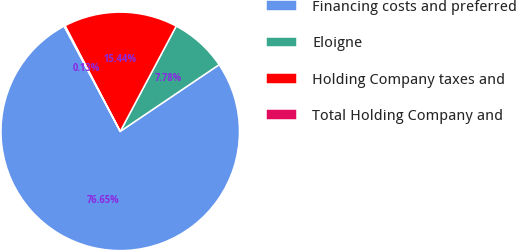Convert chart to OTSL. <chart><loc_0><loc_0><loc_500><loc_500><pie_chart><fcel>Financing costs and preferred<fcel>Eloigne<fcel>Holding Company taxes and<fcel>Total Holding Company and<nl><fcel>76.65%<fcel>7.78%<fcel>15.44%<fcel>0.13%<nl></chart> 